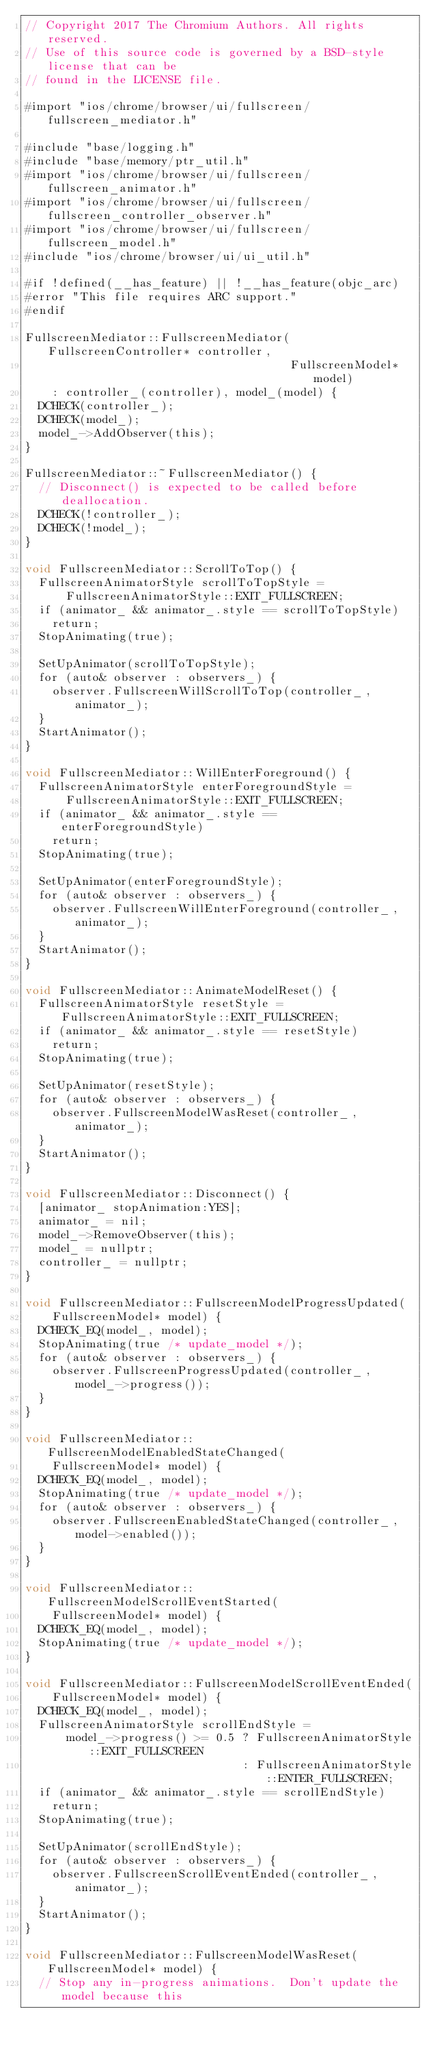<code> <loc_0><loc_0><loc_500><loc_500><_ObjectiveC_>// Copyright 2017 The Chromium Authors. All rights reserved.
// Use of this source code is governed by a BSD-style license that can be
// found in the LICENSE file.

#import "ios/chrome/browser/ui/fullscreen/fullscreen_mediator.h"

#include "base/logging.h"
#include "base/memory/ptr_util.h"
#import "ios/chrome/browser/ui/fullscreen/fullscreen_animator.h"
#import "ios/chrome/browser/ui/fullscreen/fullscreen_controller_observer.h"
#import "ios/chrome/browser/ui/fullscreen/fullscreen_model.h"
#include "ios/chrome/browser/ui/ui_util.h"

#if !defined(__has_feature) || !__has_feature(objc_arc)
#error "This file requires ARC support."
#endif

FullscreenMediator::FullscreenMediator(FullscreenController* controller,
                                       FullscreenModel* model)
    : controller_(controller), model_(model) {
  DCHECK(controller_);
  DCHECK(model_);
  model_->AddObserver(this);
}

FullscreenMediator::~FullscreenMediator() {
  // Disconnect() is expected to be called before deallocation.
  DCHECK(!controller_);
  DCHECK(!model_);
}

void FullscreenMediator::ScrollToTop() {
  FullscreenAnimatorStyle scrollToTopStyle =
      FullscreenAnimatorStyle::EXIT_FULLSCREEN;
  if (animator_ && animator_.style == scrollToTopStyle)
    return;
  StopAnimating(true);

  SetUpAnimator(scrollToTopStyle);
  for (auto& observer : observers_) {
    observer.FullscreenWillScrollToTop(controller_, animator_);
  }
  StartAnimator();
}

void FullscreenMediator::WillEnterForeground() {
  FullscreenAnimatorStyle enterForegroundStyle =
      FullscreenAnimatorStyle::EXIT_FULLSCREEN;
  if (animator_ && animator_.style == enterForegroundStyle)
    return;
  StopAnimating(true);

  SetUpAnimator(enterForegroundStyle);
  for (auto& observer : observers_) {
    observer.FullscreenWillEnterForeground(controller_, animator_);
  }
  StartAnimator();
}

void FullscreenMediator::AnimateModelReset() {
  FullscreenAnimatorStyle resetStyle = FullscreenAnimatorStyle::EXIT_FULLSCREEN;
  if (animator_ && animator_.style == resetStyle)
    return;
  StopAnimating(true);

  SetUpAnimator(resetStyle);
  for (auto& observer : observers_) {
    observer.FullscreenModelWasReset(controller_, animator_);
  }
  StartAnimator();
}

void FullscreenMediator::Disconnect() {
  [animator_ stopAnimation:YES];
  animator_ = nil;
  model_->RemoveObserver(this);
  model_ = nullptr;
  controller_ = nullptr;
}

void FullscreenMediator::FullscreenModelProgressUpdated(
    FullscreenModel* model) {
  DCHECK_EQ(model_, model);
  StopAnimating(true /* update_model */);
  for (auto& observer : observers_) {
    observer.FullscreenProgressUpdated(controller_, model_->progress());
  }
}

void FullscreenMediator::FullscreenModelEnabledStateChanged(
    FullscreenModel* model) {
  DCHECK_EQ(model_, model);
  StopAnimating(true /* update_model */);
  for (auto& observer : observers_) {
    observer.FullscreenEnabledStateChanged(controller_, model->enabled());
  }
}

void FullscreenMediator::FullscreenModelScrollEventStarted(
    FullscreenModel* model) {
  DCHECK_EQ(model_, model);
  StopAnimating(true /* update_model */);
}

void FullscreenMediator::FullscreenModelScrollEventEnded(
    FullscreenModel* model) {
  DCHECK_EQ(model_, model);
  FullscreenAnimatorStyle scrollEndStyle =
      model_->progress() >= 0.5 ? FullscreenAnimatorStyle::EXIT_FULLSCREEN
                                : FullscreenAnimatorStyle::ENTER_FULLSCREEN;
  if (animator_ && animator_.style == scrollEndStyle)
    return;
  StopAnimating(true);

  SetUpAnimator(scrollEndStyle);
  for (auto& observer : observers_) {
    observer.FullscreenScrollEventEnded(controller_, animator_);
  }
  StartAnimator();
}

void FullscreenMediator::FullscreenModelWasReset(FullscreenModel* model) {
  // Stop any in-progress animations.  Don't update the model because this</code> 